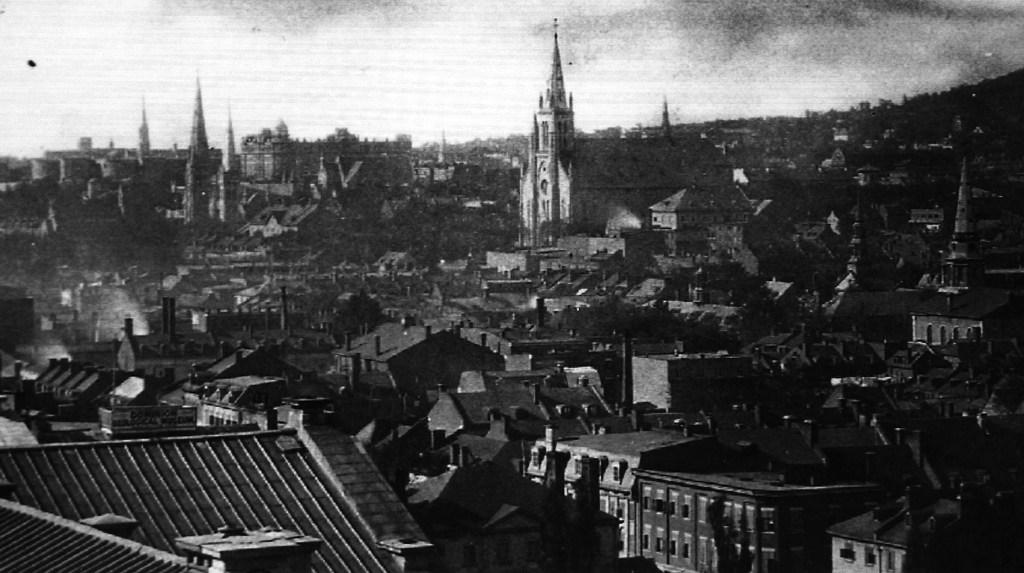What is the color scheme of the image? The image is in black and white. What types of structures can be seen in the image? There are multiple buildings in the image. What is visible at the top of the image? The sky is visible at the top of the image. How many eggs are visible in the image? There are no eggs present in the image. What type of yard can be seen in the image? There is no yard present in the image; it features multiple buildings and a visible sky. 